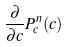Convert formula to latex. <formula><loc_0><loc_0><loc_500><loc_500>\frac { \partial } { \partial c } P _ { c } ^ { n } ( c )</formula> 